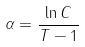Convert formula to latex. <formula><loc_0><loc_0><loc_500><loc_500>\alpha = \frac { \ln C } { T - 1 }</formula> 